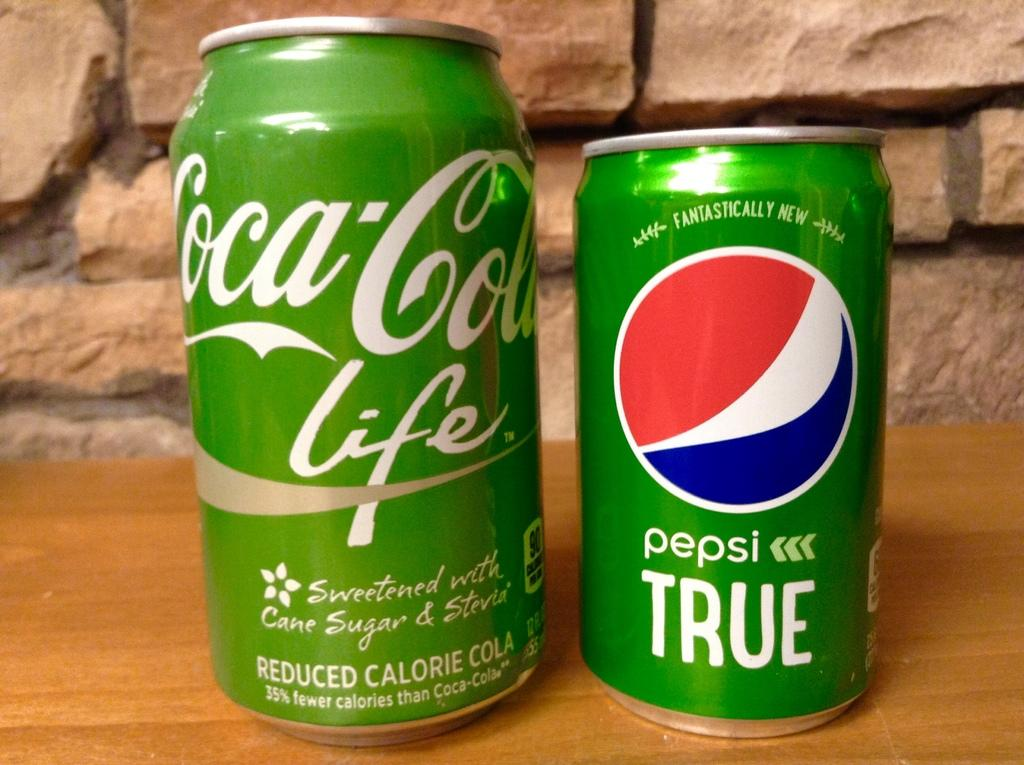Provide a one-sentence caption for the provided image. A green can of Pepsi sits next to a green can of Coke. 